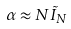<formula> <loc_0><loc_0><loc_500><loc_500>\alpha \approx N \tilde { I } _ { N }</formula> 